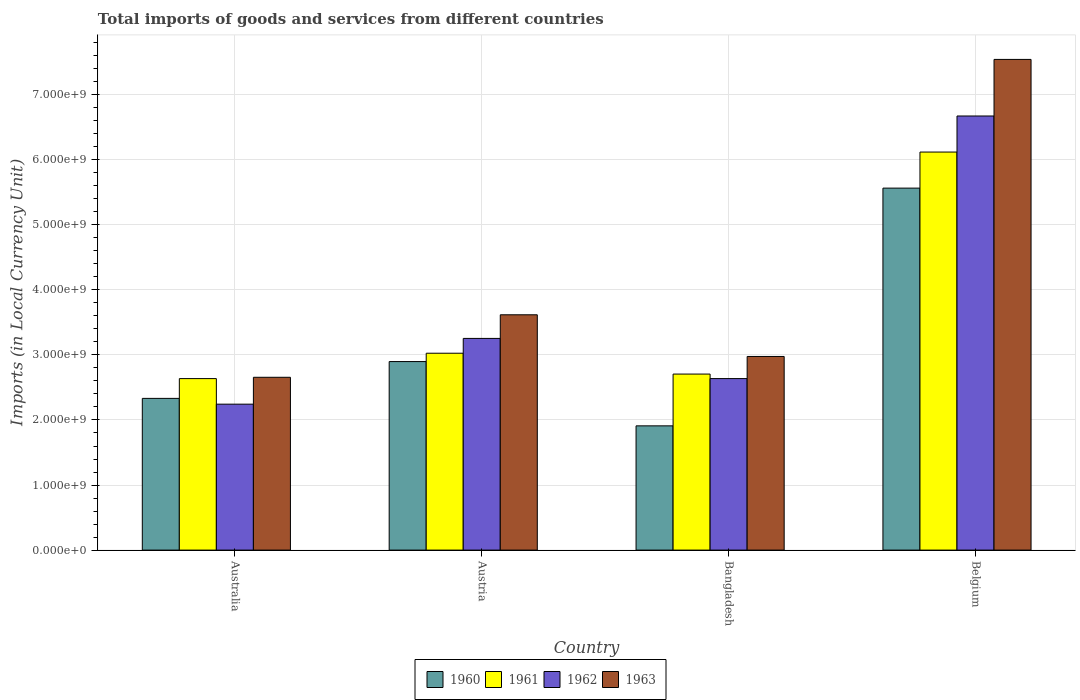How many different coloured bars are there?
Provide a short and direct response. 4. Are the number of bars per tick equal to the number of legend labels?
Keep it short and to the point. Yes. Are the number of bars on each tick of the X-axis equal?
Provide a succinct answer. Yes. How many bars are there on the 1st tick from the right?
Ensure brevity in your answer.  4. What is the label of the 4th group of bars from the left?
Your answer should be compact. Belgium. What is the Amount of goods and services imports in 1963 in Austria?
Ensure brevity in your answer.  3.62e+09. Across all countries, what is the maximum Amount of goods and services imports in 1960?
Offer a terse response. 5.56e+09. Across all countries, what is the minimum Amount of goods and services imports in 1961?
Provide a short and direct response. 2.64e+09. In which country was the Amount of goods and services imports in 1960 maximum?
Make the answer very short. Belgium. What is the total Amount of goods and services imports in 1962 in the graph?
Your answer should be compact. 1.48e+1. What is the difference between the Amount of goods and services imports in 1962 in Australia and that in Austria?
Your answer should be very brief. -1.01e+09. What is the difference between the Amount of goods and services imports in 1963 in Austria and the Amount of goods and services imports in 1960 in Australia?
Your answer should be very brief. 1.28e+09. What is the average Amount of goods and services imports in 1960 per country?
Your response must be concise. 3.18e+09. What is the difference between the Amount of goods and services imports of/in 1960 and Amount of goods and services imports of/in 1963 in Bangladesh?
Your response must be concise. -1.07e+09. In how many countries, is the Amount of goods and services imports in 1961 greater than 4200000000 LCU?
Provide a short and direct response. 1. What is the ratio of the Amount of goods and services imports in 1962 in Austria to that in Belgium?
Your response must be concise. 0.49. Is the Amount of goods and services imports in 1960 in Austria less than that in Belgium?
Provide a short and direct response. Yes. Is the difference between the Amount of goods and services imports in 1960 in Australia and Bangladesh greater than the difference between the Amount of goods and services imports in 1963 in Australia and Bangladesh?
Provide a succinct answer. Yes. What is the difference between the highest and the second highest Amount of goods and services imports in 1963?
Provide a short and direct response. 3.93e+09. What is the difference between the highest and the lowest Amount of goods and services imports in 1963?
Offer a terse response. 4.89e+09. In how many countries, is the Amount of goods and services imports in 1960 greater than the average Amount of goods and services imports in 1960 taken over all countries?
Offer a very short reply. 1. Is the sum of the Amount of goods and services imports in 1962 in Bangladesh and Belgium greater than the maximum Amount of goods and services imports in 1963 across all countries?
Your answer should be compact. Yes. Is it the case that in every country, the sum of the Amount of goods and services imports in 1963 and Amount of goods and services imports in 1962 is greater than the sum of Amount of goods and services imports in 1961 and Amount of goods and services imports in 1960?
Your answer should be compact. No. What does the 1st bar from the right in Austria represents?
Your answer should be compact. 1963. Is it the case that in every country, the sum of the Amount of goods and services imports in 1961 and Amount of goods and services imports in 1963 is greater than the Amount of goods and services imports in 1960?
Provide a succinct answer. Yes. Are all the bars in the graph horizontal?
Your response must be concise. No. How many countries are there in the graph?
Your answer should be very brief. 4. Are the values on the major ticks of Y-axis written in scientific E-notation?
Keep it short and to the point. Yes. Does the graph contain any zero values?
Provide a short and direct response. No. Where does the legend appear in the graph?
Your response must be concise. Bottom center. How are the legend labels stacked?
Offer a terse response. Horizontal. What is the title of the graph?
Your response must be concise. Total imports of goods and services from different countries. Does "1969" appear as one of the legend labels in the graph?
Your answer should be compact. No. What is the label or title of the X-axis?
Give a very brief answer. Country. What is the label or title of the Y-axis?
Give a very brief answer. Imports (in Local Currency Unit). What is the Imports (in Local Currency Unit) of 1960 in Australia?
Make the answer very short. 2.33e+09. What is the Imports (in Local Currency Unit) of 1961 in Australia?
Your response must be concise. 2.64e+09. What is the Imports (in Local Currency Unit) in 1962 in Australia?
Offer a terse response. 2.24e+09. What is the Imports (in Local Currency Unit) of 1963 in Australia?
Provide a short and direct response. 2.66e+09. What is the Imports (in Local Currency Unit) of 1960 in Austria?
Offer a terse response. 2.90e+09. What is the Imports (in Local Currency Unit) in 1961 in Austria?
Make the answer very short. 3.03e+09. What is the Imports (in Local Currency Unit) of 1962 in Austria?
Provide a short and direct response. 3.25e+09. What is the Imports (in Local Currency Unit) in 1963 in Austria?
Provide a succinct answer. 3.62e+09. What is the Imports (in Local Currency Unit) of 1960 in Bangladesh?
Offer a very short reply. 1.91e+09. What is the Imports (in Local Currency Unit) in 1961 in Bangladesh?
Provide a short and direct response. 2.71e+09. What is the Imports (in Local Currency Unit) of 1962 in Bangladesh?
Your answer should be very brief. 2.64e+09. What is the Imports (in Local Currency Unit) of 1963 in Bangladesh?
Provide a short and direct response. 2.98e+09. What is the Imports (in Local Currency Unit) of 1960 in Belgium?
Your answer should be very brief. 5.56e+09. What is the Imports (in Local Currency Unit) of 1961 in Belgium?
Keep it short and to the point. 6.12e+09. What is the Imports (in Local Currency Unit) in 1962 in Belgium?
Offer a very short reply. 6.67e+09. What is the Imports (in Local Currency Unit) in 1963 in Belgium?
Your response must be concise. 7.54e+09. Across all countries, what is the maximum Imports (in Local Currency Unit) in 1960?
Offer a very short reply. 5.56e+09. Across all countries, what is the maximum Imports (in Local Currency Unit) of 1961?
Offer a very short reply. 6.12e+09. Across all countries, what is the maximum Imports (in Local Currency Unit) of 1962?
Your answer should be compact. 6.67e+09. Across all countries, what is the maximum Imports (in Local Currency Unit) in 1963?
Give a very brief answer. 7.54e+09. Across all countries, what is the minimum Imports (in Local Currency Unit) of 1960?
Keep it short and to the point. 1.91e+09. Across all countries, what is the minimum Imports (in Local Currency Unit) of 1961?
Your response must be concise. 2.64e+09. Across all countries, what is the minimum Imports (in Local Currency Unit) in 1962?
Offer a terse response. 2.24e+09. Across all countries, what is the minimum Imports (in Local Currency Unit) in 1963?
Provide a short and direct response. 2.66e+09. What is the total Imports (in Local Currency Unit) of 1960 in the graph?
Offer a very short reply. 1.27e+1. What is the total Imports (in Local Currency Unit) of 1961 in the graph?
Your answer should be compact. 1.45e+1. What is the total Imports (in Local Currency Unit) in 1962 in the graph?
Your answer should be very brief. 1.48e+1. What is the total Imports (in Local Currency Unit) in 1963 in the graph?
Offer a very short reply. 1.68e+1. What is the difference between the Imports (in Local Currency Unit) in 1960 in Australia and that in Austria?
Provide a short and direct response. -5.66e+08. What is the difference between the Imports (in Local Currency Unit) in 1961 in Australia and that in Austria?
Your response must be concise. -3.90e+08. What is the difference between the Imports (in Local Currency Unit) of 1962 in Australia and that in Austria?
Your response must be concise. -1.01e+09. What is the difference between the Imports (in Local Currency Unit) of 1963 in Australia and that in Austria?
Provide a short and direct response. -9.61e+08. What is the difference between the Imports (in Local Currency Unit) of 1960 in Australia and that in Bangladesh?
Provide a succinct answer. 4.22e+08. What is the difference between the Imports (in Local Currency Unit) in 1961 in Australia and that in Bangladesh?
Your answer should be very brief. -6.96e+07. What is the difference between the Imports (in Local Currency Unit) of 1962 in Australia and that in Bangladesh?
Provide a succinct answer. -3.93e+08. What is the difference between the Imports (in Local Currency Unit) in 1963 in Australia and that in Bangladesh?
Offer a terse response. -3.20e+08. What is the difference between the Imports (in Local Currency Unit) of 1960 in Australia and that in Belgium?
Your answer should be compact. -3.23e+09. What is the difference between the Imports (in Local Currency Unit) of 1961 in Australia and that in Belgium?
Your answer should be compact. -3.48e+09. What is the difference between the Imports (in Local Currency Unit) of 1962 in Australia and that in Belgium?
Your response must be concise. -4.43e+09. What is the difference between the Imports (in Local Currency Unit) of 1963 in Australia and that in Belgium?
Offer a terse response. -4.89e+09. What is the difference between the Imports (in Local Currency Unit) of 1960 in Austria and that in Bangladesh?
Keep it short and to the point. 9.88e+08. What is the difference between the Imports (in Local Currency Unit) in 1961 in Austria and that in Bangladesh?
Give a very brief answer. 3.20e+08. What is the difference between the Imports (in Local Currency Unit) of 1962 in Austria and that in Bangladesh?
Make the answer very short. 6.18e+08. What is the difference between the Imports (in Local Currency Unit) in 1963 in Austria and that in Bangladesh?
Give a very brief answer. 6.41e+08. What is the difference between the Imports (in Local Currency Unit) in 1960 in Austria and that in Belgium?
Provide a short and direct response. -2.67e+09. What is the difference between the Imports (in Local Currency Unit) of 1961 in Austria and that in Belgium?
Offer a terse response. -3.09e+09. What is the difference between the Imports (in Local Currency Unit) of 1962 in Austria and that in Belgium?
Your answer should be compact. -3.42e+09. What is the difference between the Imports (in Local Currency Unit) in 1963 in Austria and that in Belgium?
Your answer should be compact. -3.93e+09. What is the difference between the Imports (in Local Currency Unit) in 1960 in Bangladesh and that in Belgium?
Offer a very short reply. -3.65e+09. What is the difference between the Imports (in Local Currency Unit) in 1961 in Bangladesh and that in Belgium?
Offer a very short reply. -3.41e+09. What is the difference between the Imports (in Local Currency Unit) of 1962 in Bangladesh and that in Belgium?
Keep it short and to the point. -4.04e+09. What is the difference between the Imports (in Local Currency Unit) in 1963 in Bangladesh and that in Belgium?
Ensure brevity in your answer.  -4.57e+09. What is the difference between the Imports (in Local Currency Unit) in 1960 in Australia and the Imports (in Local Currency Unit) in 1961 in Austria?
Offer a terse response. -6.94e+08. What is the difference between the Imports (in Local Currency Unit) in 1960 in Australia and the Imports (in Local Currency Unit) in 1962 in Austria?
Your response must be concise. -9.22e+08. What is the difference between the Imports (in Local Currency Unit) of 1960 in Australia and the Imports (in Local Currency Unit) of 1963 in Austria?
Your response must be concise. -1.28e+09. What is the difference between the Imports (in Local Currency Unit) of 1961 in Australia and the Imports (in Local Currency Unit) of 1962 in Austria?
Make the answer very short. -6.18e+08. What is the difference between the Imports (in Local Currency Unit) of 1961 in Australia and the Imports (in Local Currency Unit) of 1963 in Austria?
Keep it short and to the point. -9.81e+08. What is the difference between the Imports (in Local Currency Unit) of 1962 in Australia and the Imports (in Local Currency Unit) of 1963 in Austria?
Ensure brevity in your answer.  -1.37e+09. What is the difference between the Imports (in Local Currency Unit) of 1960 in Australia and the Imports (in Local Currency Unit) of 1961 in Bangladesh?
Make the answer very short. -3.74e+08. What is the difference between the Imports (in Local Currency Unit) in 1960 in Australia and the Imports (in Local Currency Unit) in 1962 in Bangladesh?
Provide a succinct answer. -3.04e+08. What is the difference between the Imports (in Local Currency Unit) in 1960 in Australia and the Imports (in Local Currency Unit) in 1963 in Bangladesh?
Ensure brevity in your answer.  -6.44e+08. What is the difference between the Imports (in Local Currency Unit) in 1961 in Australia and the Imports (in Local Currency Unit) in 1962 in Bangladesh?
Offer a terse response. -1.80e+05. What is the difference between the Imports (in Local Currency Unit) in 1961 in Australia and the Imports (in Local Currency Unit) in 1963 in Bangladesh?
Your answer should be compact. -3.40e+08. What is the difference between the Imports (in Local Currency Unit) in 1962 in Australia and the Imports (in Local Currency Unit) in 1963 in Bangladesh?
Make the answer very short. -7.33e+08. What is the difference between the Imports (in Local Currency Unit) in 1960 in Australia and the Imports (in Local Currency Unit) in 1961 in Belgium?
Provide a short and direct response. -3.79e+09. What is the difference between the Imports (in Local Currency Unit) in 1960 in Australia and the Imports (in Local Currency Unit) in 1962 in Belgium?
Keep it short and to the point. -4.34e+09. What is the difference between the Imports (in Local Currency Unit) of 1960 in Australia and the Imports (in Local Currency Unit) of 1963 in Belgium?
Offer a very short reply. -5.21e+09. What is the difference between the Imports (in Local Currency Unit) in 1961 in Australia and the Imports (in Local Currency Unit) in 1962 in Belgium?
Your response must be concise. -4.04e+09. What is the difference between the Imports (in Local Currency Unit) in 1961 in Australia and the Imports (in Local Currency Unit) in 1963 in Belgium?
Give a very brief answer. -4.91e+09. What is the difference between the Imports (in Local Currency Unit) of 1962 in Australia and the Imports (in Local Currency Unit) of 1963 in Belgium?
Provide a short and direct response. -5.30e+09. What is the difference between the Imports (in Local Currency Unit) of 1960 in Austria and the Imports (in Local Currency Unit) of 1961 in Bangladesh?
Your answer should be very brief. 1.92e+08. What is the difference between the Imports (in Local Currency Unit) of 1960 in Austria and the Imports (in Local Currency Unit) of 1962 in Bangladesh?
Your response must be concise. 2.62e+08. What is the difference between the Imports (in Local Currency Unit) of 1960 in Austria and the Imports (in Local Currency Unit) of 1963 in Bangladesh?
Provide a short and direct response. -7.85e+07. What is the difference between the Imports (in Local Currency Unit) of 1961 in Austria and the Imports (in Local Currency Unit) of 1962 in Bangladesh?
Ensure brevity in your answer.  3.90e+08. What is the difference between the Imports (in Local Currency Unit) in 1961 in Austria and the Imports (in Local Currency Unit) in 1963 in Bangladesh?
Your answer should be very brief. 4.96e+07. What is the difference between the Imports (in Local Currency Unit) of 1962 in Austria and the Imports (in Local Currency Unit) of 1963 in Bangladesh?
Your response must be concise. 2.77e+08. What is the difference between the Imports (in Local Currency Unit) in 1960 in Austria and the Imports (in Local Currency Unit) in 1961 in Belgium?
Your answer should be compact. -3.22e+09. What is the difference between the Imports (in Local Currency Unit) in 1960 in Austria and the Imports (in Local Currency Unit) in 1962 in Belgium?
Provide a succinct answer. -3.77e+09. What is the difference between the Imports (in Local Currency Unit) of 1960 in Austria and the Imports (in Local Currency Unit) of 1963 in Belgium?
Offer a very short reply. -4.64e+09. What is the difference between the Imports (in Local Currency Unit) in 1961 in Austria and the Imports (in Local Currency Unit) in 1962 in Belgium?
Offer a terse response. -3.65e+09. What is the difference between the Imports (in Local Currency Unit) of 1961 in Austria and the Imports (in Local Currency Unit) of 1963 in Belgium?
Your response must be concise. -4.52e+09. What is the difference between the Imports (in Local Currency Unit) of 1962 in Austria and the Imports (in Local Currency Unit) of 1963 in Belgium?
Ensure brevity in your answer.  -4.29e+09. What is the difference between the Imports (in Local Currency Unit) in 1960 in Bangladesh and the Imports (in Local Currency Unit) in 1961 in Belgium?
Offer a very short reply. -4.21e+09. What is the difference between the Imports (in Local Currency Unit) in 1960 in Bangladesh and the Imports (in Local Currency Unit) in 1962 in Belgium?
Give a very brief answer. -4.76e+09. What is the difference between the Imports (in Local Currency Unit) in 1960 in Bangladesh and the Imports (in Local Currency Unit) in 1963 in Belgium?
Provide a short and direct response. -5.63e+09. What is the difference between the Imports (in Local Currency Unit) of 1961 in Bangladesh and the Imports (in Local Currency Unit) of 1962 in Belgium?
Offer a terse response. -3.97e+09. What is the difference between the Imports (in Local Currency Unit) of 1961 in Bangladesh and the Imports (in Local Currency Unit) of 1963 in Belgium?
Your response must be concise. -4.84e+09. What is the difference between the Imports (in Local Currency Unit) of 1962 in Bangladesh and the Imports (in Local Currency Unit) of 1963 in Belgium?
Offer a very short reply. -4.91e+09. What is the average Imports (in Local Currency Unit) of 1960 per country?
Make the answer very short. 3.18e+09. What is the average Imports (in Local Currency Unit) in 1961 per country?
Make the answer very short. 3.62e+09. What is the average Imports (in Local Currency Unit) of 1962 per country?
Provide a short and direct response. 3.70e+09. What is the average Imports (in Local Currency Unit) of 1963 per country?
Offer a terse response. 4.20e+09. What is the difference between the Imports (in Local Currency Unit) of 1960 and Imports (in Local Currency Unit) of 1961 in Australia?
Your response must be concise. -3.04e+08. What is the difference between the Imports (in Local Currency Unit) of 1960 and Imports (in Local Currency Unit) of 1962 in Australia?
Offer a very short reply. 8.90e+07. What is the difference between the Imports (in Local Currency Unit) in 1960 and Imports (in Local Currency Unit) in 1963 in Australia?
Your response must be concise. -3.24e+08. What is the difference between the Imports (in Local Currency Unit) in 1961 and Imports (in Local Currency Unit) in 1962 in Australia?
Offer a terse response. 3.93e+08. What is the difference between the Imports (in Local Currency Unit) in 1961 and Imports (in Local Currency Unit) in 1963 in Australia?
Your response must be concise. -2.00e+07. What is the difference between the Imports (in Local Currency Unit) in 1962 and Imports (in Local Currency Unit) in 1963 in Australia?
Make the answer very short. -4.13e+08. What is the difference between the Imports (in Local Currency Unit) in 1960 and Imports (in Local Currency Unit) in 1961 in Austria?
Offer a very short reply. -1.28e+08. What is the difference between the Imports (in Local Currency Unit) of 1960 and Imports (in Local Currency Unit) of 1962 in Austria?
Keep it short and to the point. -3.56e+08. What is the difference between the Imports (in Local Currency Unit) in 1960 and Imports (in Local Currency Unit) in 1963 in Austria?
Your response must be concise. -7.19e+08. What is the difference between the Imports (in Local Currency Unit) in 1961 and Imports (in Local Currency Unit) in 1962 in Austria?
Provide a short and direct response. -2.28e+08. What is the difference between the Imports (in Local Currency Unit) in 1961 and Imports (in Local Currency Unit) in 1963 in Austria?
Your response must be concise. -5.91e+08. What is the difference between the Imports (in Local Currency Unit) of 1962 and Imports (in Local Currency Unit) of 1963 in Austria?
Provide a succinct answer. -3.63e+08. What is the difference between the Imports (in Local Currency Unit) of 1960 and Imports (in Local Currency Unit) of 1961 in Bangladesh?
Offer a terse response. -7.96e+08. What is the difference between the Imports (in Local Currency Unit) of 1960 and Imports (in Local Currency Unit) of 1962 in Bangladesh?
Offer a very short reply. -7.26e+08. What is the difference between the Imports (in Local Currency Unit) in 1960 and Imports (in Local Currency Unit) in 1963 in Bangladesh?
Your answer should be very brief. -1.07e+09. What is the difference between the Imports (in Local Currency Unit) of 1961 and Imports (in Local Currency Unit) of 1962 in Bangladesh?
Offer a very short reply. 6.94e+07. What is the difference between the Imports (in Local Currency Unit) of 1961 and Imports (in Local Currency Unit) of 1963 in Bangladesh?
Give a very brief answer. -2.71e+08. What is the difference between the Imports (in Local Currency Unit) of 1962 and Imports (in Local Currency Unit) of 1963 in Bangladesh?
Provide a short and direct response. -3.40e+08. What is the difference between the Imports (in Local Currency Unit) in 1960 and Imports (in Local Currency Unit) in 1961 in Belgium?
Provide a succinct answer. -5.54e+08. What is the difference between the Imports (in Local Currency Unit) of 1960 and Imports (in Local Currency Unit) of 1962 in Belgium?
Provide a succinct answer. -1.11e+09. What is the difference between the Imports (in Local Currency Unit) of 1960 and Imports (in Local Currency Unit) of 1963 in Belgium?
Offer a terse response. -1.98e+09. What is the difference between the Imports (in Local Currency Unit) of 1961 and Imports (in Local Currency Unit) of 1962 in Belgium?
Your response must be concise. -5.54e+08. What is the difference between the Imports (in Local Currency Unit) of 1961 and Imports (in Local Currency Unit) of 1963 in Belgium?
Keep it short and to the point. -1.42e+09. What is the difference between the Imports (in Local Currency Unit) in 1962 and Imports (in Local Currency Unit) in 1963 in Belgium?
Provide a succinct answer. -8.70e+08. What is the ratio of the Imports (in Local Currency Unit) in 1960 in Australia to that in Austria?
Offer a terse response. 0.8. What is the ratio of the Imports (in Local Currency Unit) in 1961 in Australia to that in Austria?
Your answer should be very brief. 0.87. What is the ratio of the Imports (in Local Currency Unit) of 1962 in Australia to that in Austria?
Offer a very short reply. 0.69. What is the ratio of the Imports (in Local Currency Unit) of 1963 in Australia to that in Austria?
Give a very brief answer. 0.73. What is the ratio of the Imports (in Local Currency Unit) of 1960 in Australia to that in Bangladesh?
Ensure brevity in your answer.  1.22. What is the ratio of the Imports (in Local Currency Unit) of 1961 in Australia to that in Bangladesh?
Give a very brief answer. 0.97. What is the ratio of the Imports (in Local Currency Unit) in 1962 in Australia to that in Bangladesh?
Your response must be concise. 0.85. What is the ratio of the Imports (in Local Currency Unit) of 1963 in Australia to that in Bangladesh?
Your response must be concise. 0.89. What is the ratio of the Imports (in Local Currency Unit) of 1960 in Australia to that in Belgium?
Your answer should be compact. 0.42. What is the ratio of the Imports (in Local Currency Unit) of 1961 in Australia to that in Belgium?
Offer a very short reply. 0.43. What is the ratio of the Imports (in Local Currency Unit) of 1962 in Australia to that in Belgium?
Your answer should be very brief. 0.34. What is the ratio of the Imports (in Local Currency Unit) of 1963 in Australia to that in Belgium?
Ensure brevity in your answer.  0.35. What is the ratio of the Imports (in Local Currency Unit) in 1960 in Austria to that in Bangladesh?
Provide a succinct answer. 1.52. What is the ratio of the Imports (in Local Currency Unit) in 1961 in Austria to that in Bangladesh?
Provide a succinct answer. 1.12. What is the ratio of the Imports (in Local Currency Unit) of 1962 in Austria to that in Bangladesh?
Ensure brevity in your answer.  1.23. What is the ratio of the Imports (in Local Currency Unit) in 1963 in Austria to that in Bangladesh?
Keep it short and to the point. 1.22. What is the ratio of the Imports (in Local Currency Unit) in 1960 in Austria to that in Belgium?
Provide a short and direct response. 0.52. What is the ratio of the Imports (in Local Currency Unit) in 1961 in Austria to that in Belgium?
Keep it short and to the point. 0.49. What is the ratio of the Imports (in Local Currency Unit) of 1962 in Austria to that in Belgium?
Keep it short and to the point. 0.49. What is the ratio of the Imports (in Local Currency Unit) in 1963 in Austria to that in Belgium?
Provide a short and direct response. 0.48. What is the ratio of the Imports (in Local Currency Unit) of 1960 in Bangladesh to that in Belgium?
Give a very brief answer. 0.34. What is the ratio of the Imports (in Local Currency Unit) of 1961 in Bangladesh to that in Belgium?
Your answer should be very brief. 0.44. What is the ratio of the Imports (in Local Currency Unit) in 1962 in Bangladesh to that in Belgium?
Your response must be concise. 0.4. What is the ratio of the Imports (in Local Currency Unit) of 1963 in Bangladesh to that in Belgium?
Offer a very short reply. 0.39. What is the difference between the highest and the second highest Imports (in Local Currency Unit) in 1960?
Make the answer very short. 2.67e+09. What is the difference between the highest and the second highest Imports (in Local Currency Unit) in 1961?
Offer a terse response. 3.09e+09. What is the difference between the highest and the second highest Imports (in Local Currency Unit) in 1962?
Make the answer very short. 3.42e+09. What is the difference between the highest and the second highest Imports (in Local Currency Unit) of 1963?
Offer a terse response. 3.93e+09. What is the difference between the highest and the lowest Imports (in Local Currency Unit) in 1960?
Your response must be concise. 3.65e+09. What is the difference between the highest and the lowest Imports (in Local Currency Unit) of 1961?
Your answer should be compact. 3.48e+09. What is the difference between the highest and the lowest Imports (in Local Currency Unit) in 1962?
Provide a short and direct response. 4.43e+09. What is the difference between the highest and the lowest Imports (in Local Currency Unit) in 1963?
Your response must be concise. 4.89e+09. 